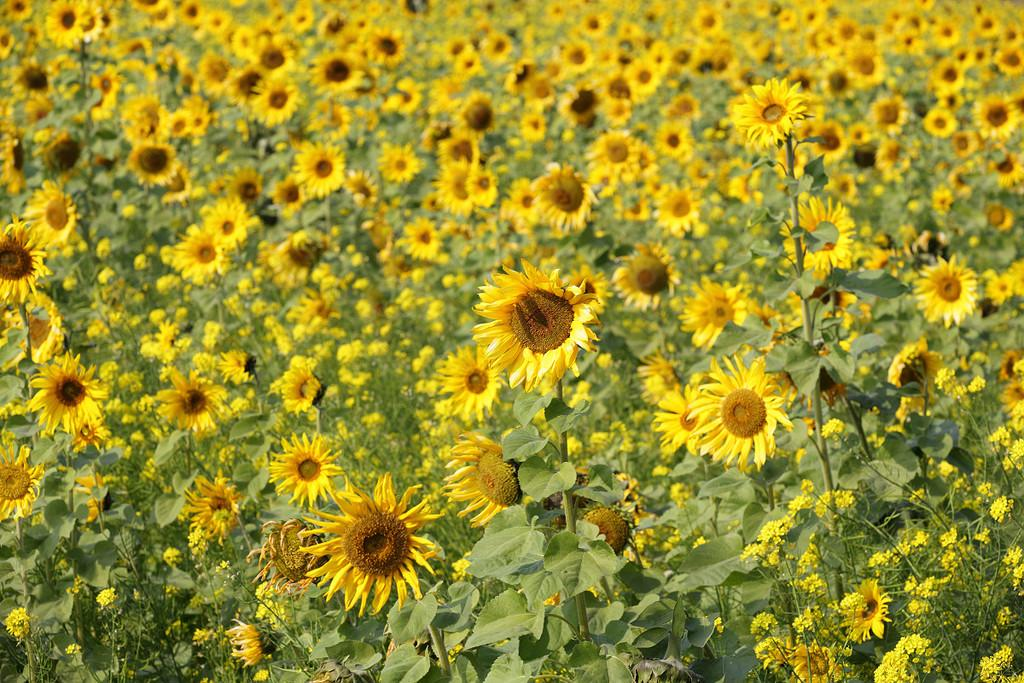What type of plants can be seen in the image? There is a group of plants in the image, which includes sunflowers. Can you describe the specific plants in the group? The group of plants includes sunflowers. How many beggars are present in the image? There are no beggars present in the image; it features a group of plants, including sunflowers. What type of marble can be seen in the image? There is no marble present in the image; it features a group of plants, including sunflowers. 